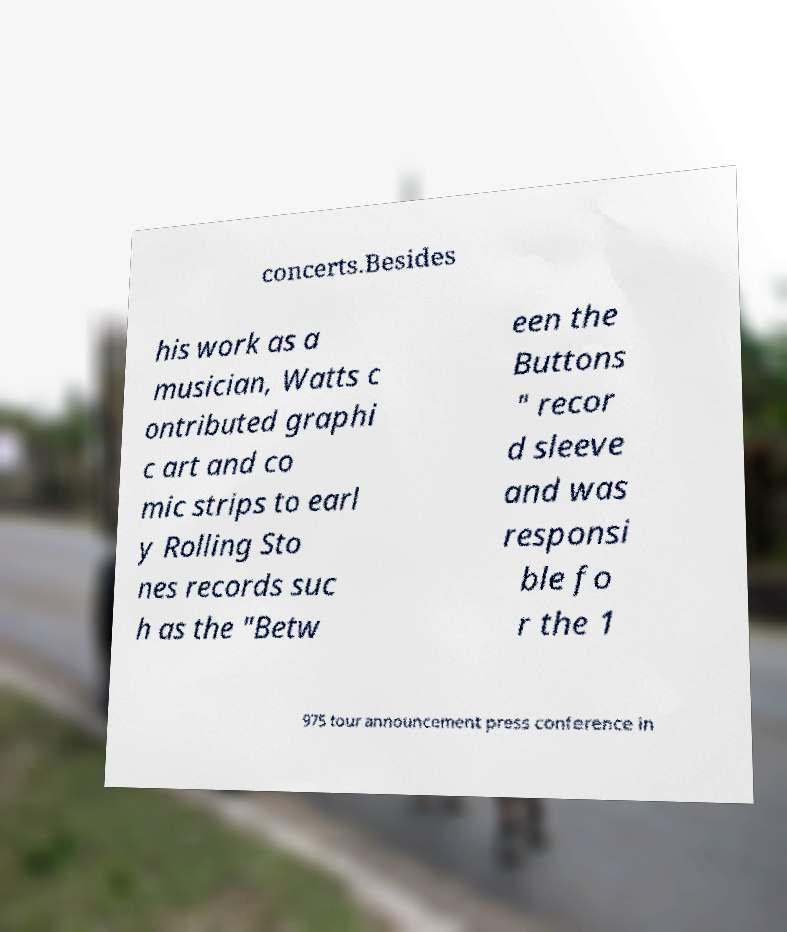For documentation purposes, I need the text within this image transcribed. Could you provide that? concerts.Besides his work as a musician, Watts c ontributed graphi c art and co mic strips to earl y Rolling Sto nes records suc h as the "Betw een the Buttons " recor d sleeve and was responsi ble fo r the 1 975 tour announcement press conference in 